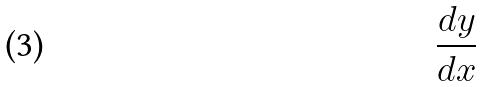Convert formula to latex. <formula><loc_0><loc_0><loc_500><loc_500>\frac { d y } { d x }</formula> 